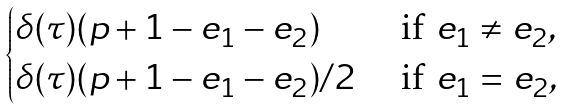<formula> <loc_0><loc_0><loc_500><loc_500>\begin{cases} \delta ( \tau ) ( p + 1 - e _ { 1 } - e _ { 2 } ) & \text { if } e _ { 1 } \neq e _ { 2 } , \\ \delta ( \tau ) ( p + 1 - e _ { 1 } - e _ { 2 } ) / 2 & \text { if } e _ { 1 } = e _ { 2 } , \end{cases}</formula> 